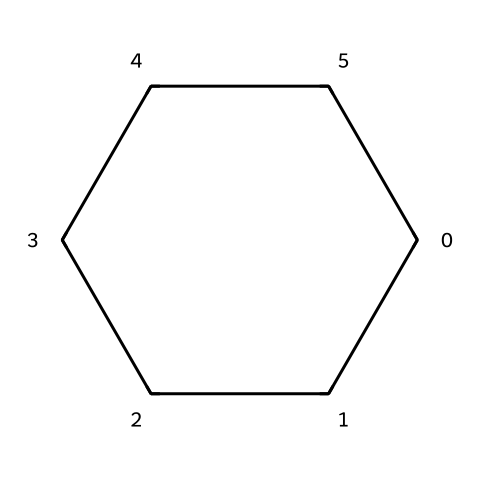What is the molecular formula of the compound? The SMILES representation indicates a six-membered carbon ring (C6) with no additional atoms or functional groups. Therefore, the molecular formula is C6H12, as each carbon in the cyclohexane can bond with two hydrogens.
Answer: C6H12 How many hydrogen atoms are bonded to each carbon atom in this cycloalkane? In cyclohexane, each of the six carbons can bond to two hydrogens (as seen in its saturated structure), giving a total of 12 hydrogen atoms bonded throughout the ring.
Answer: 2 What is the name of the compound represented by this SMILES? The structure depicted corresponds to a common cycloalkane that consists of a six-membered carbon ring, known specifically as cyclohexane.
Answer: cyclohexane What type of conformational isomerism is observed in cyclohexane? Cyclohexane exhibits two primary conformational isomers: the chair and boat forms, which differ in their spatial arrangement of atoms while maintaining the same chemical connectivity.
Answer: conformational isomerism What are the two main stability factors comparing chair and boat conformations? The chair conformation is more stable than the boat conformation due to reduced steric strain and better angle strain, with more significant hydrogen interactions in the chair form.
Answer: steric strain, angle strain How does the chair-boat interconversion impact computational modeling? Understanding chair-boat interconversion provides insight into the flexibility and energy profiles of cyclohexane, which is crucial for accurate molecular simulations and predicting reactive pathways in computational chemistry.
Answer: energy profiles What is the main reason for the preference of chair conformation in cyclohexane? The chair conformation minimizes torsional strain and steric hindrance in cyclohexane, allowing for more favorable bonding angles and geometry around carbon atoms.
Answer: torsional strain 